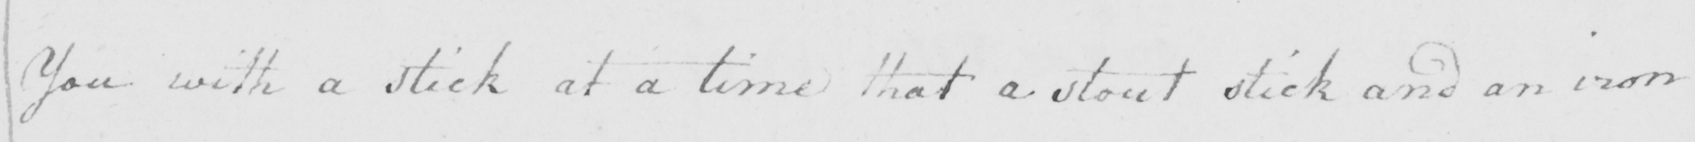What is written in this line of handwriting? You with a stick at a time that a stout stick and an iron 